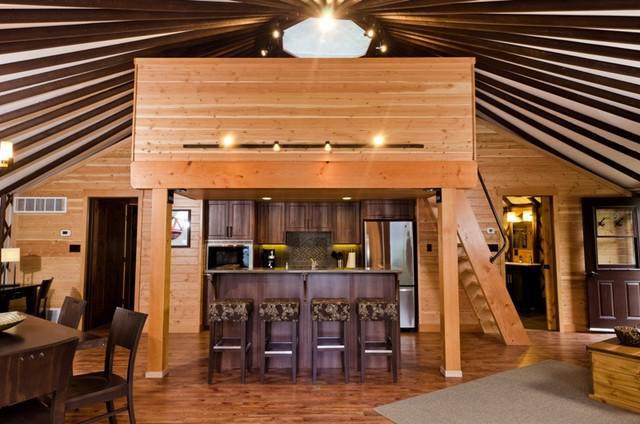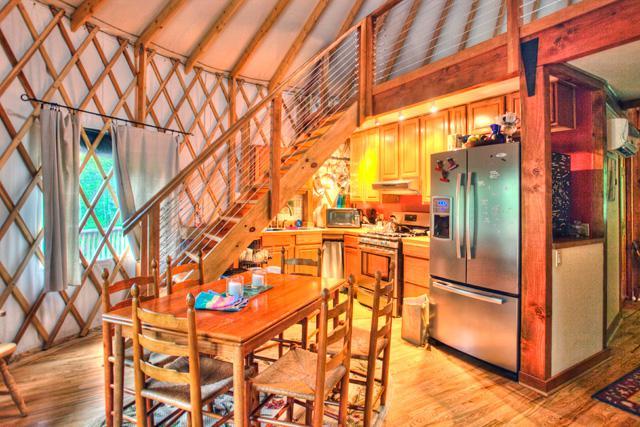The first image is the image on the left, the second image is the image on the right. For the images shown, is this caption "There are at least two stools in one of the images." true? Answer yes or no. Yes. 